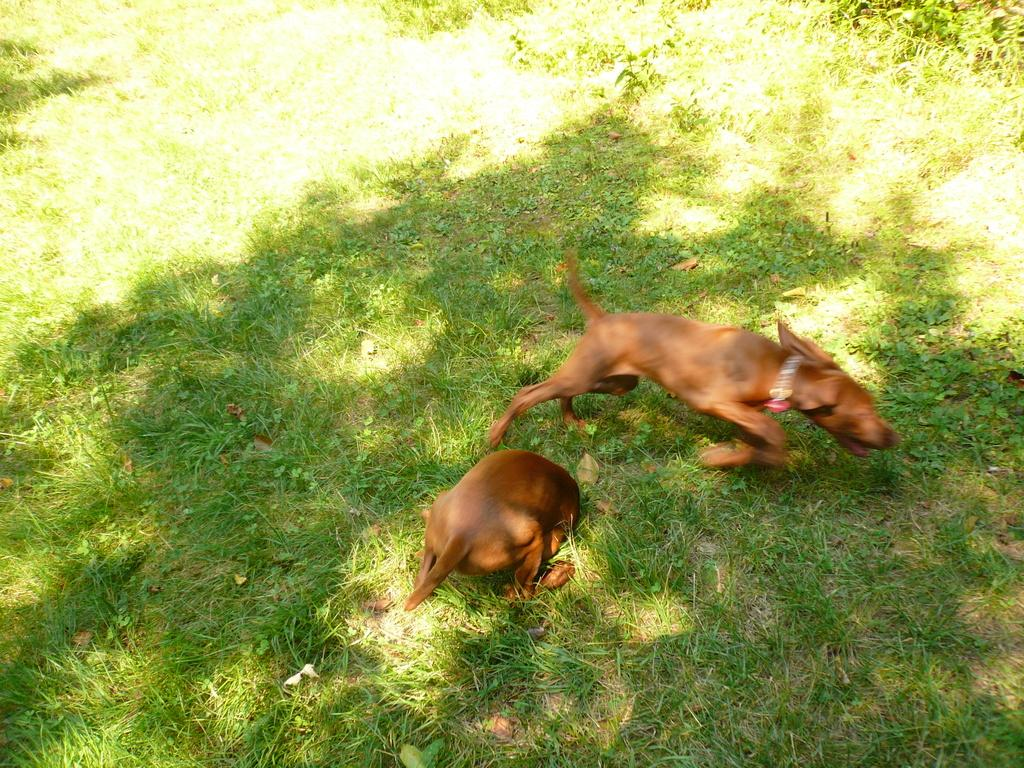What type of surface is visible on the ground in the image? There is grass on the ground in the image. What animals can be seen on the ground in the image? There are two dogs on the ground in the image. What type of ice can be seen in the stocking worn by the man in the image? There is no man or stocking present in the image; it features grass and two dogs. 